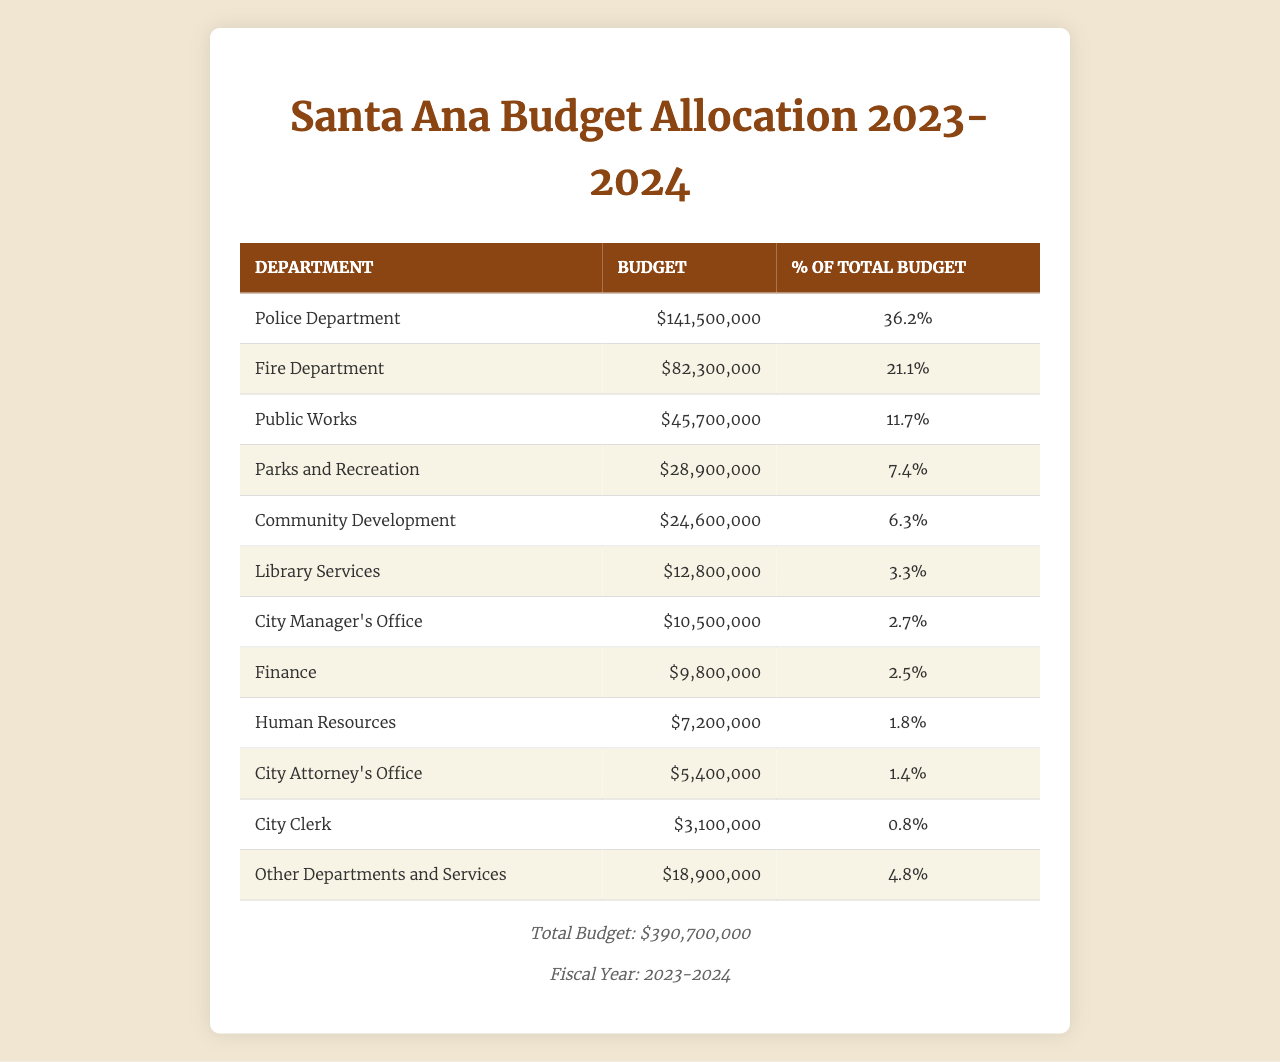What is the budget allocated to the Police Department? The table shows that the budget for the Police Department is listed as $141,500,000.
Answer: $141,500,000 What percentage of the total budget is allocated to the Fire Department? The table indicates that the budget percentage for the Fire Department is 21.1%.
Answer: 21.1% What is the total budget for the City Manager's Office and Finance combined? To find the combined budget, add the City Manager's Office budget of $10,500,000 and Finance's budget of $9,800,000. This totals $10,500,000 + $9,800,000 = $20,300,000.
Answer: $20,300,000 Is the budget for Library Services greater than 5% of the total budget? The budget for Library Services is $12,800,000, and when calculated as a percentage of the total budget ($390,700,000), it is only about 3.3%. Thus, it is not greater than 5%.
Answer: No Which department has the smallest budget allocation? By examining the budget figures in the table, Human Resources has the smallest budget at $7,200,000.
Answer: Human Resources What is the budget difference between the Public Works department and Parks and Recreation? The budget for Public Works is $45,700,000 while Parks and Recreation has a budget of $28,900,000. The difference is calculated as $45,700,000 - $28,900,000 = $16,800,000.
Answer: $16,800,000 If you combine the budgets of Community Development and Library Services, do they make up more than 10% of the total budget? Community Development has a budget of $24,600,000 and Library Services has $12,800,000, totaling $24,600,000 + $12,800,000 = $37,400,000. To find the percentage, divide by the total budget: $37,400,000 / $390,700,000 = approximately 9.6%, which is less than 10%.
Answer: No What is the total budget for all departments except for the Police and Fire Departments? The total budget for the Police and Fire Departments is $141,500,000 + $82,300,000 = $223,800,000. Subtracting this from the overall total budget of $390,700,000 yields $390,700,000 - $223,800,000 = $166,900,000.
Answer: $166,900,000 What percentage of the total budget is allocated to "Other Departments and Services"? The budget for "Other Departments and Services" is $18,900,000. To find the percentage, calculate ($18,900,000 / $390,700,000) * 100 which equals about 4.8%.
Answer: 4.8% Is the combined budget of the City Attorney's Office and City Clerk greater than $8 million? The City Attorney's Office has a budget of $5,400,000 and the City Clerk has $3,100,000. Their combined budget totals $5,400,000 + $3,100,000 = $8,500,000, which is greater than $8 million.
Answer: Yes 